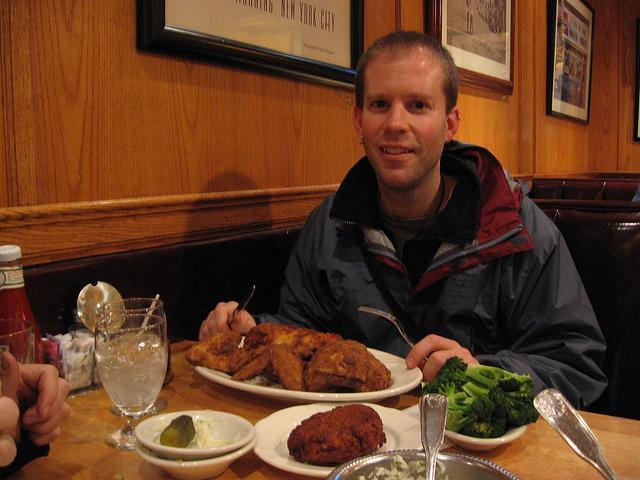How many pieces of chicken is on this man's plate?
Give a very brief answer. 4. How many faces are there with glasses?
Give a very brief answer. 0. How many bowls are visible?
Give a very brief answer. 2. How many people are there?
Give a very brief answer. 2. 